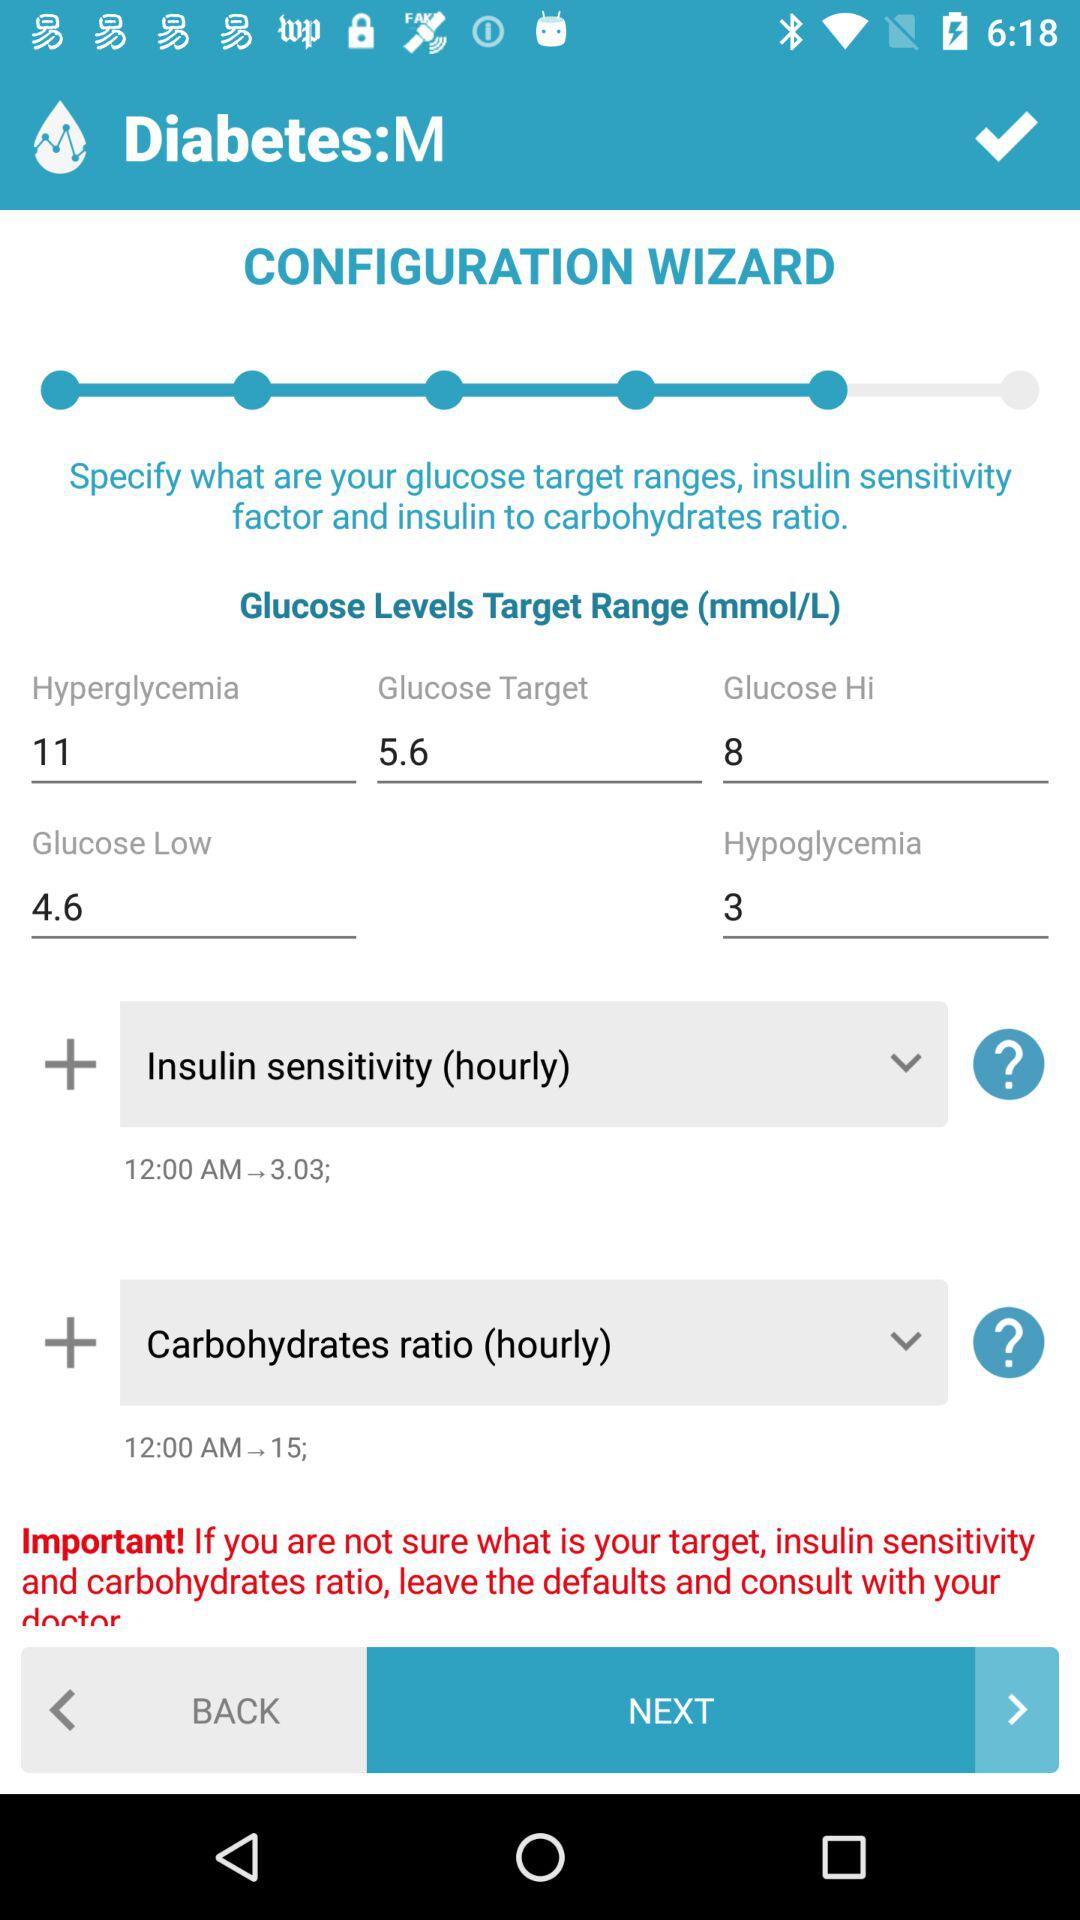At 12:00 am, what is the insulin to carbohydrate ratio? The insulin to carbohydrate ratio is 15. 